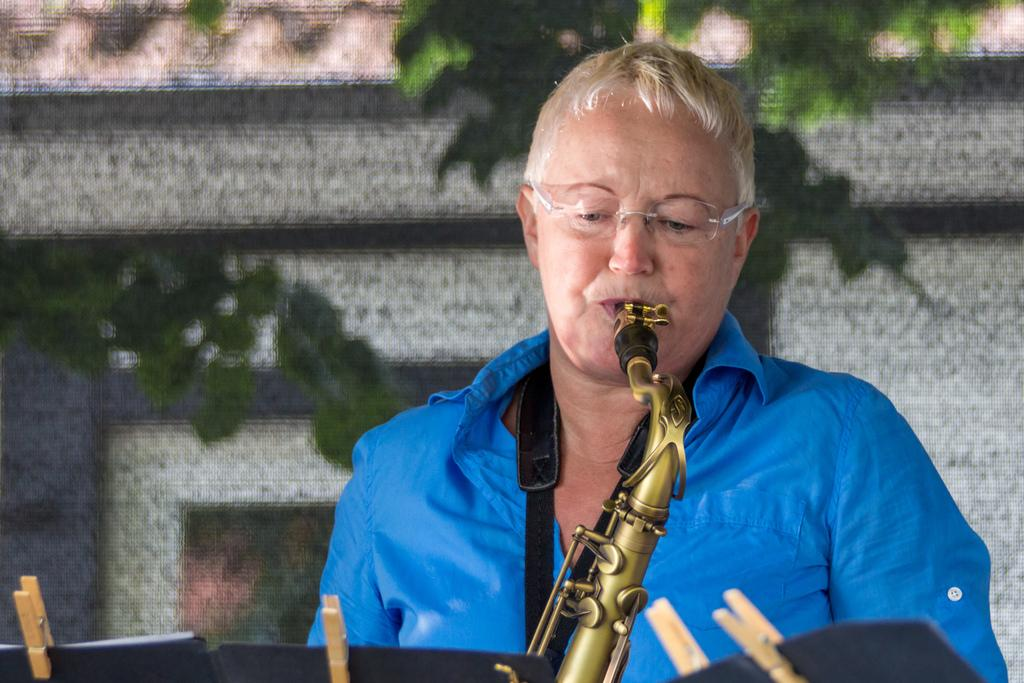What is present in the image? There is a person in the image. Can you describe the person's appearance? The person is wearing clothes and spectacles. What else can be seen in the image? There are clips and a musical instrument visible. How would you describe the background of the image? The background of the image is blurred. Is there a picture of a rainstorm in the image? No, there is no picture of a rainstorm in the image. Can you see any beans in the image? No, there are no beans present in the image. 